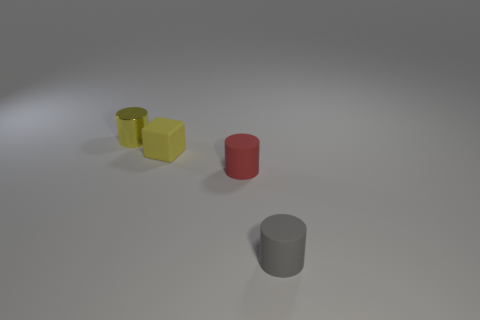Are there any other things that have the same material as the tiny yellow cylinder?
Make the answer very short. No. Is the material of the yellow thing that is in front of the small yellow metallic thing the same as the yellow cylinder?
Keep it short and to the point. No. What number of things are yellow shiny objects or small cylinders on the left side of the yellow rubber block?
Your response must be concise. 1. How many tiny matte objects are in front of the cylinder behind the yellow thing that is in front of the tiny yellow metal object?
Make the answer very short. 3. Do the yellow thing that is in front of the metal thing and the gray rubber object have the same shape?
Your response must be concise. No. Is there a small yellow matte thing that is to the right of the tiny rubber cylinder left of the tiny gray cylinder?
Your answer should be very brief. No. How many tiny brown rubber cylinders are there?
Your answer should be compact. 0. There is a cylinder that is behind the gray matte object and right of the small yellow cylinder; what color is it?
Ensure brevity in your answer.  Red. The metallic object that is the same shape as the gray rubber object is what size?
Your answer should be very brief. Small. What number of yellow rubber objects have the same size as the gray rubber cylinder?
Your answer should be compact. 1. 